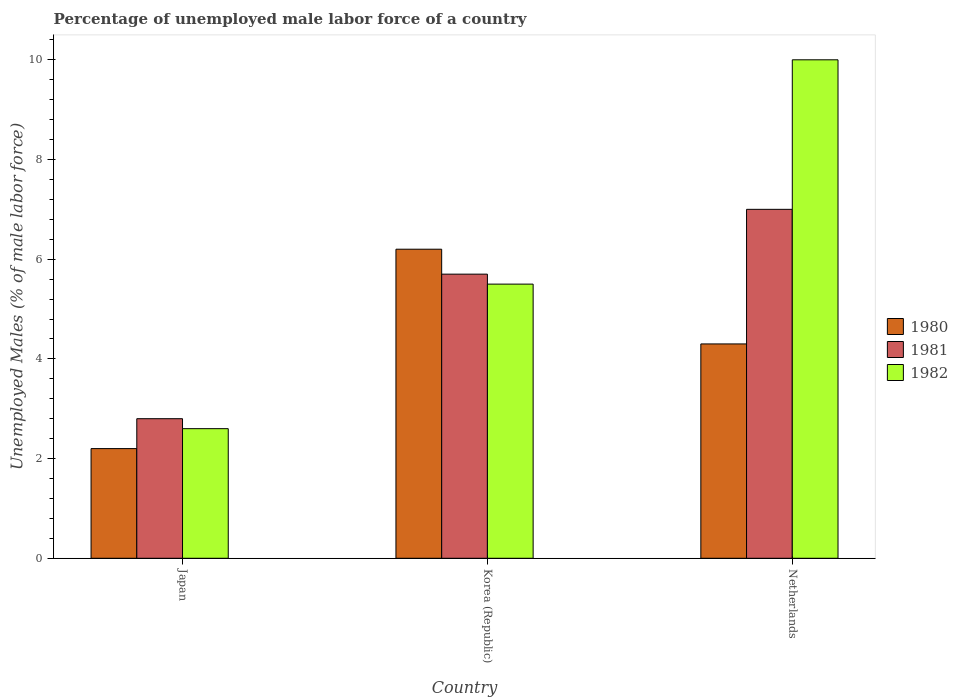How many bars are there on the 3rd tick from the left?
Offer a terse response. 3. What is the label of the 1st group of bars from the left?
Your answer should be compact. Japan. What is the percentage of unemployed male labor force in 1981 in Netherlands?
Give a very brief answer. 7. Across all countries, what is the maximum percentage of unemployed male labor force in 1982?
Offer a very short reply. 10. Across all countries, what is the minimum percentage of unemployed male labor force in 1981?
Give a very brief answer. 2.8. In which country was the percentage of unemployed male labor force in 1981 minimum?
Provide a succinct answer. Japan. What is the total percentage of unemployed male labor force in 1982 in the graph?
Your response must be concise. 18.1. What is the difference between the percentage of unemployed male labor force in 1980 in Japan and that in Netherlands?
Ensure brevity in your answer.  -2.1. What is the difference between the percentage of unemployed male labor force in 1982 in Netherlands and the percentage of unemployed male labor force in 1981 in Korea (Republic)?
Keep it short and to the point. 4.3. What is the average percentage of unemployed male labor force in 1982 per country?
Make the answer very short. 6.03. What is the difference between the percentage of unemployed male labor force of/in 1982 and percentage of unemployed male labor force of/in 1980 in Netherlands?
Your answer should be compact. 5.7. What is the ratio of the percentage of unemployed male labor force in 1982 in Japan to that in Netherlands?
Your answer should be compact. 0.26. Is the percentage of unemployed male labor force in 1982 in Korea (Republic) less than that in Netherlands?
Offer a terse response. Yes. Is the difference between the percentage of unemployed male labor force in 1982 in Korea (Republic) and Netherlands greater than the difference between the percentage of unemployed male labor force in 1980 in Korea (Republic) and Netherlands?
Provide a succinct answer. No. What is the difference between the highest and the second highest percentage of unemployed male labor force in 1980?
Ensure brevity in your answer.  -2.1. What is the difference between the highest and the lowest percentage of unemployed male labor force in 1980?
Make the answer very short. 4. Are all the bars in the graph horizontal?
Your answer should be very brief. No. How many countries are there in the graph?
Offer a terse response. 3. Are the values on the major ticks of Y-axis written in scientific E-notation?
Provide a succinct answer. No. Does the graph contain any zero values?
Make the answer very short. No. Does the graph contain grids?
Offer a terse response. No. Where does the legend appear in the graph?
Your answer should be very brief. Center right. What is the title of the graph?
Provide a succinct answer. Percentage of unemployed male labor force of a country. What is the label or title of the Y-axis?
Keep it short and to the point. Unemployed Males (% of male labor force). What is the Unemployed Males (% of male labor force) of 1980 in Japan?
Your answer should be compact. 2.2. What is the Unemployed Males (% of male labor force) in 1981 in Japan?
Ensure brevity in your answer.  2.8. What is the Unemployed Males (% of male labor force) of 1982 in Japan?
Give a very brief answer. 2.6. What is the Unemployed Males (% of male labor force) of 1980 in Korea (Republic)?
Keep it short and to the point. 6.2. What is the Unemployed Males (% of male labor force) of 1981 in Korea (Republic)?
Provide a short and direct response. 5.7. What is the Unemployed Males (% of male labor force) of 1982 in Korea (Republic)?
Ensure brevity in your answer.  5.5. What is the Unemployed Males (% of male labor force) in 1980 in Netherlands?
Provide a succinct answer. 4.3. What is the Unemployed Males (% of male labor force) of 1981 in Netherlands?
Offer a terse response. 7. What is the Unemployed Males (% of male labor force) in 1982 in Netherlands?
Keep it short and to the point. 10. Across all countries, what is the maximum Unemployed Males (% of male labor force) in 1980?
Provide a succinct answer. 6.2. Across all countries, what is the minimum Unemployed Males (% of male labor force) of 1980?
Offer a terse response. 2.2. Across all countries, what is the minimum Unemployed Males (% of male labor force) of 1981?
Provide a succinct answer. 2.8. Across all countries, what is the minimum Unemployed Males (% of male labor force) of 1982?
Keep it short and to the point. 2.6. What is the total Unemployed Males (% of male labor force) in 1980 in the graph?
Offer a very short reply. 12.7. What is the difference between the Unemployed Males (% of male labor force) in 1980 in Japan and that in Korea (Republic)?
Provide a succinct answer. -4. What is the difference between the Unemployed Males (% of male labor force) in 1981 in Japan and that in Korea (Republic)?
Your answer should be very brief. -2.9. What is the difference between the Unemployed Males (% of male labor force) of 1982 in Japan and that in Korea (Republic)?
Keep it short and to the point. -2.9. What is the difference between the Unemployed Males (% of male labor force) in 1980 in Korea (Republic) and that in Netherlands?
Your response must be concise. 1.9. What is the difference between the Unemployed Males (% of male labor force) of 1982 in Korea (Republic) and that in Netherlands?
Your response must be concise. -4.5. What is the difference between the Unemployed Males (% of male labor force) in 1981 in Japan and the Unemployed Males (% of male labor force) in 1982 in Netherlands?
Your response must be concise. -7.2. What is the difference between the Unemployed Males (% of male labor force) in 1980 in Korea (Republic) and the Unemployed Males (% of male labor force) in 1981 in Netherlands?
Offer a terse response. -0.8. What is the difference between the Unemployed Males (% of male labor force) in 1980 in Korea (Republic) and the Unemployed Males (% of male labor force) in 1982 in Netherlands?
Your response must be concise. -3.8. What is the difference between the Unemployed Males (% of male labor force) in 1981 in Korea (Republic) and the Unemployed Males (% of male labor force) in 1982 in Netherlands?
Keep it short and to the point. -4.3. What is the average Unemployed Males (% of male labor force) of 1980 per country?
Provide a short and direct response. 4.23. What is the average Unemployed Males (% of male labor force) of 1981 per country?
Provide a succinct answer. 5.17. What is the average Unemployed Males (% of male labor force) in 1982 per country?
Keep it short and to the point. 6.03. What is the difference between the Unemployed Males (% of male labor force) in 1980 and Unemployed Males (% of male labor force) in 1981 in Japan?
Give a very brief answer. -0.6. What is the difference between the Unemployed Males (% of male labor force) of 1980 and Unemployed Males (% of male labor force) of 1982 in Japan?
Give a very brief answer. -0.4. What is the difference between the Unemployed Males (% of male labor force) of 1981 and Unemployed Males (% of male labor force) of 1982 in Japan?
Provide a succinct answer. 0.2. What is the difference between the Unemployed Males (% of male labor force) of 1981 and Unemployed Males (% of male labor force) of 1982 in Korea (Republic)?
Your answer should be compact. 0.2. What is the difference between the Unemployed Males (% of male labor force) in 1980 and Unemployed Males (% of male labor force) in 1982 in Netherlands?
Your response must be concise. -5.7. What is the difference between the Unemployed Males (% of male labor force) in 1981 and Unemployed Males (% of male labor force) in 1982 in Netherlands?
Ensure brevity in your answer.  -3. What is the ratio of the Unemployed Males (% of male labor force) of 1980 in Japan to that in Korea (Republic)?
Offer a very short reply. 0.35. What is the ratio of the Unemployed Males (% of male labor force) in 1981 in Japan to that in Korea (Republic)?
Make the answer very short. 0.49. What is the ratio of the Unemployed Males (% of male labor force) in 1982 in Japan to that in Korea (Republic)?
Provide a short and direct response. 0.47. What is the ratio of the Unemployed Males (% of male labor force) in 1980 in Japan to that in Netherlands?
Offer a terse response. 0.51. What is the ratio of the Unemployed Males (% of male labor force) in 1982 in Japan to that in Netherlands?
Offer a terse response. 0.26. What is the ratio of the Unemployed Males (% of male labor force) in 1980 in Korea (Republic) to that in Netherlands?
Offer a terse response. 1.44. What is the ratio of the Unemployed Males (% of male labor force) of 1981 in Korea (Republic) to that in Netherlands?
Your answer should be very brief. 0.81. What is the ratio of the Unemployed Males (% of male labor force) of 1982 in Korea (Republic) to that in Netherlands?
Your answer should be very brief. 0.55. What is the difference between the highest and the second highest Unemployed Males (% of male labor force) in 1980?
Your answer should be compact. 1.9. What is the difference between the highest and the lowest Unemployed Males (% of male labor force) in 1980?
Offer a terse response. 4. 